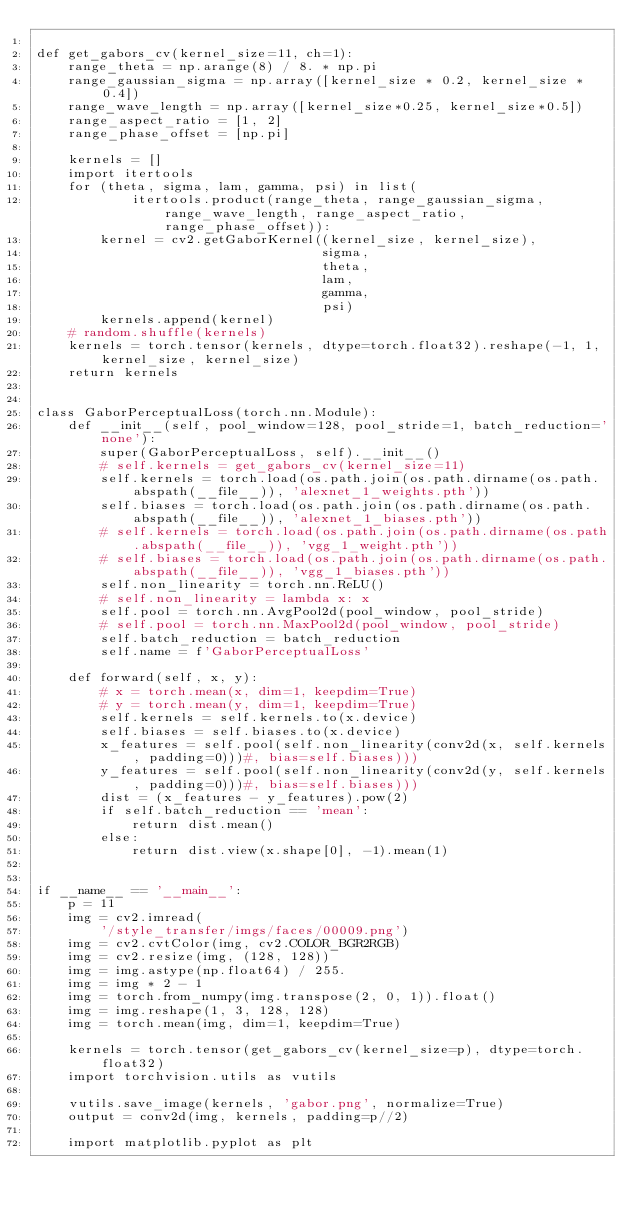<code> <loc_0><loc_0><loc_500><loc_500><_Python_>
def get_gabors_cv(kernel_size=11, ch=1):
    range_theta = np.arange(8) / 8. * np.pi
    range_gaussian_sigma = np.array([kernel_size * 0.2, kernel_size * 0.4])
    range_wave_length = np.array([kernel_size*0.25, kernel_size*0.5])
    range_aspect_ratio = [1, 2]
    range_phase_offset = [np.pi]

    kernels = []
    import itertools
    for (theta, sigma, lam, gamma, psi) in list(
            itertools.product(range_theta, range_gaussian_sigma, range_wave_length, range_aspect_ratio,range_phase_offset)):
        kernel = cv2.getGaborKernel((kernel_size, kernel_size),
                                    sigma,
                                    theta,
                                    lam,
                                    gamma,
                                    psi)
        kernels.append(kernel)
    # random.shuffle(kernels)
    kernels = torch.tensor(kernels, dtype=torch.float32).reshape(-1, 1, kernel_size, kernel_size)
    return kernels


class GaborPerceptualLoss(torch.nn.Module):
    def __init__(self, pool_window=128, pool_stride=1, batch_reduction='none'):
        super(GaborPerceptualLoss, self).__init__()
        # self.kernels = get_gabors_cv(kernel_size=11)
        self.kernels = torch.load(os.path.join(os.path.dirname(os.path.abspath(__file__)), 'alexnet_1_weights.pth'))
        self.biases = torch.load(os.path.join(os.path.dirname(os.path.abspath(__file__)), 'alexnet_1_biases.pth'))
        # self.kernels = torch.load(os.path.join(os.path.dirname(os.path.abspath(__file__)), 'vgg_1_weight.pth'))
        # self.biases = torch.load(os.path.join(os.path.dirname(os.path.abspath(__file__)), 'vgg_1_biases.pth'))
        self.non_linearity = torch.nn.ReLU()
        # self.non_linearity = lambda x: x
        self.pool = torch.nn.AvgPool2d(pool_window, pool_stride)
        # self.pool = torch.nn.MaxPool2d(pool_window, pool_stride)
        self.batch_reduction = batch_reduction
        self.name = f'GaborPerceptualLoss'

    def forward(self, x, y):
        # x = torch.mean(x, dim=1, keepdim=True)
        # y = torch.mean(y, dim=1, keepdim=True)
        self.kernels = self.kernels.to(x.device)
        self.biases = self.biases.to(x.device)
        x_features = self.pool(self.non_linearity(conv2d(x, self.kernels, padding=0)))#, bias=self.biases)))
        y_features = self.pool(self.non_linearity(conv2d(y, self.kernels, padding=0)))#, bias=self.biases)))
        dist = (x_features - y_features).pow(2)
        if self.batch_reduction == 'mean':
            return dist.mean()
        else:
            return dist.view(x.shape[0], -1).mean(1)


if __name__ == '__main__':
    p = 11
    img = cv2.imread(
        '/style_transfer/imgs/faces/00009.png')
    img = cv2.cvtColor(img, cv2.COLOR_BGR2RGB)
    img = cv2.resize(img, (128, 128))
    img = img.astype(np.float64) / 255.
    img = img * 2 - 1
    img = torch.from_numpy(img.transpose(2, 0, 1)).float()
    img = img.reshape(1, 3, 128, 128)
    img = torch.mean(img, dim=1, keepdim=True)

    kernels = torch.tensor(get_gabors_cv(kernel_size=p), dtype=torch.float32)
    import torchvision.utils as vutils

    vutils.save_image(kernels, 'gabor.png', normalize=True)
    output = conv2d(img, kernels, padding=p//2)

    import matplotlib.pyplot as plt
</code> 